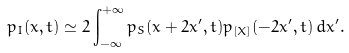<formula> <loc_0><loc_0><loc_500><loc_500>p _ { I } ( x , t ) \simeq 2 \int _ { - \infty } ^ { + \infty } p _ { S } ( x + 2 x ^ { \prime } , t ) p _ { [ X ] } ( - 2 x ^ { \prime } , t ) \, d x ^ { \prime } .</formula> 